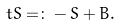Convert formula to latex. <formula><loc_0><loc_0><loc_500><loc_500>\ t S = \colon - S + B .</formula> 